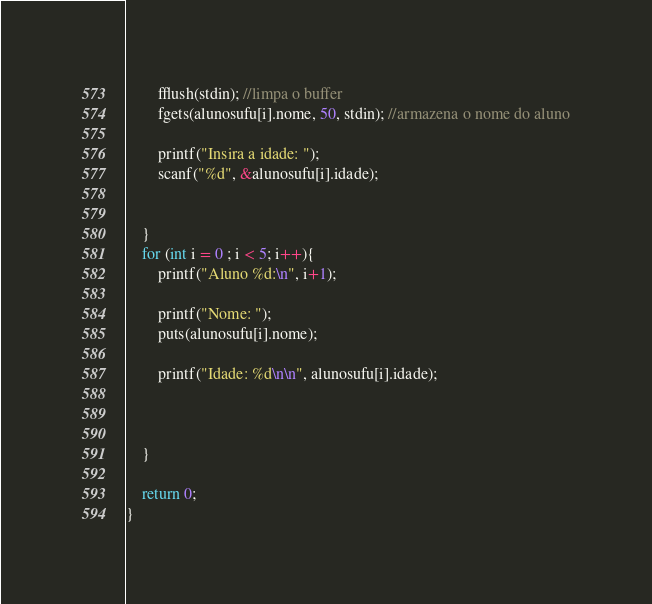<code> <loc_0><loc_0><loc_500><loc_500><_C_>        fflush(stdin); //limpa o buffer
        fgets(alunosufu[i].nome, 50, stdin); //armazena o nome do aluno

        printf("Insira a idade: ");
        scanf("%d", &alunosufu[i].idade);


    }
    for (int i = 0 ; i < 5; i++){
        printf("Aluno %d:\n", i+1);

        printf("Nome: ");
        puts(alunosufu[i].nome);

        printf("Idade: %d\n\n", alunosufu[i].idade);
    


    }

    return 0;
}</code> 